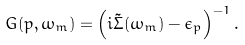Convert formula to latex. <formula><loc_0><loc_0><loc_500><loc_500>G ( p , \omega _ { m } ) = \left ( i { \tilde { \Sigma } } ( \omega _ { m } ) - \epsilon _ { p } \right ) ^ { - 1 } .</formula> 